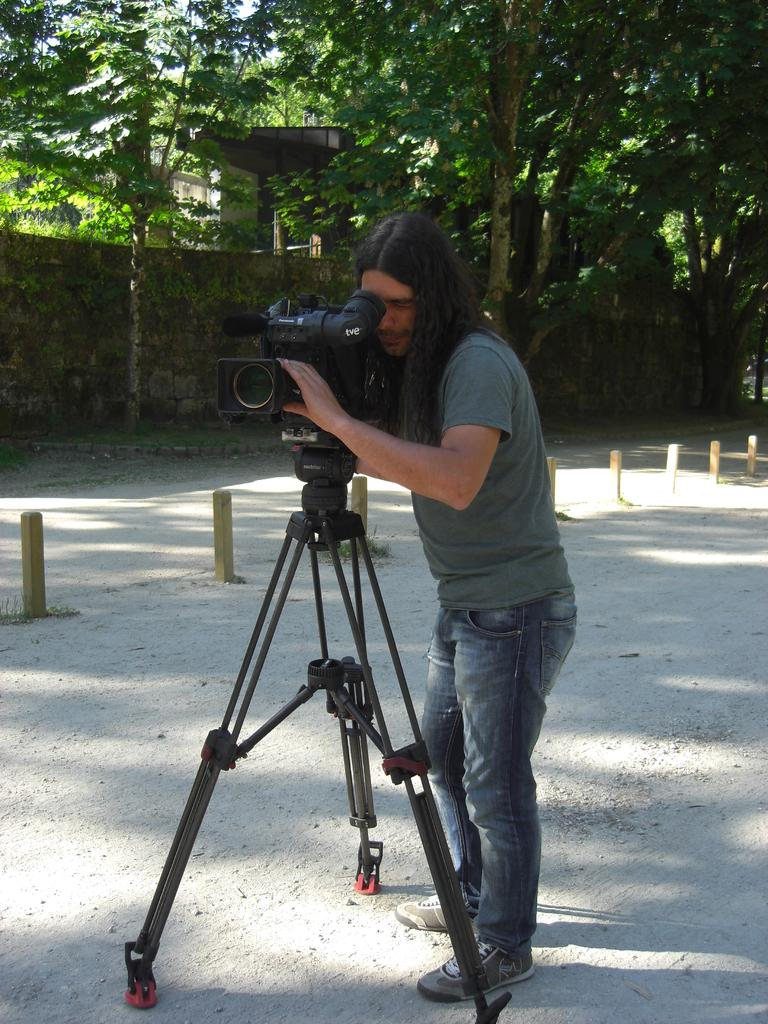What is the main subject in the image? There is a person standing in the image. What equipment is visible in the image? There is a camera with a tripod stand in the image. What can be seen in the background of the image? There is a wall, a house, and trees in the background of the image. What is the person's sense of humor like in the image? There is no information about the person's sense of humor in the image. 